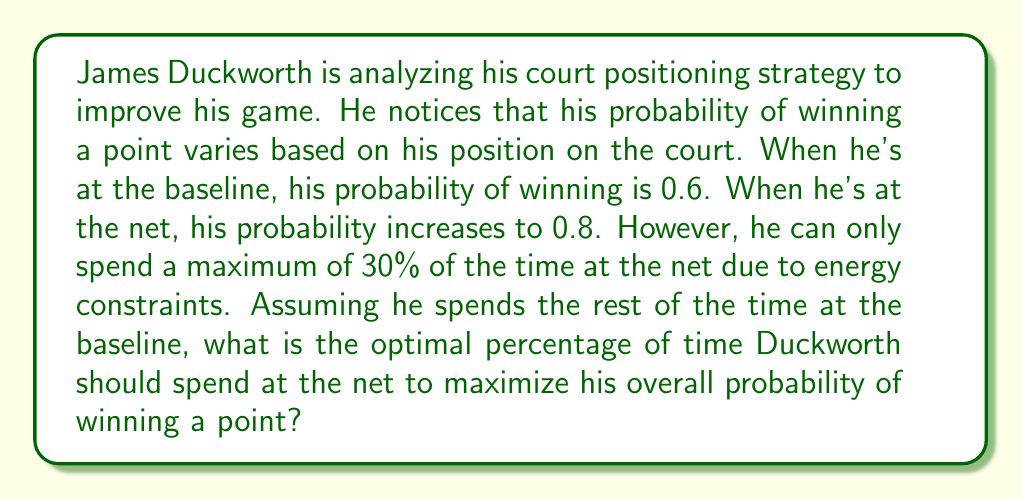Help me with this question. Let's approach this step-by-step using linear programming concepts:

1) Let $x$ be the fraction of time Duckworth spends at the net.

2) The objective function to maximize is the overall probability of winning a point:

   $P(win) = 0.8x + 0.6(1-x)$

3) The constraint is that Duckworth can spend at most 30% of the time at the net:

   $0 \leq x \leq 0.3$

4) Simplifying the objective function:

   $P(win) = 0.8x + 0.6 - 0.6x = 0.6 + 0.2x$

5) This is a linear function of $x$. In a linear programming problem with a single variable and upper/lower bounds, the optimal solution will always be at one of the bounds.

6) To determine which bound gives the maximum:

   At $x = 0$: $P(win) = 0.6$
   At $x = 0.3$: $P(win) = 0.6 + 0.2(0.3) = 0.66$

7) Clearly, the maximum occurs at $x = 0.3$, which is 30%.

Therefore, to maximize his probability of winning a point, Duckworth should spend the maximum allowed time (30%) at the net.
Answer: Duckworth should spend 30% of his time at the net to maximize his overall probability of winning a point. 